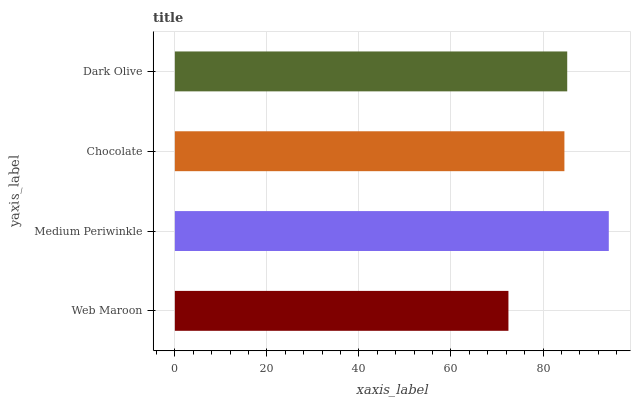Is Web Maroon the minimum?
Answer yes or no. Yes. Is Medium Periwinkle the maximum?
Answer yes or no. Yes. Is Chocolate the minimum?
Answer yes or no. No. Is Chocolate the maximum?
Answer yes or no. No. Is Medium Periwinkle greater than Chocolate?
Answer yes or no. Yes. Is Chocolate less than Medium Periwinkle?
Answer yes or no. Yes. Is Chocolate greater than Medium Periwinkle?
Answer yes or no. No. Is Medium Periwinkle less than Chocolate?
Answer yes or no. No. Is Dark Olive the high median?
Answer yes or no. Yes. Is Chocolate the low median?
Answer yes or no. Yes. Is Chocolate the high median?
Answer yes or no. No. Is Dark Olive the low median?
Answer yes or no. No. 